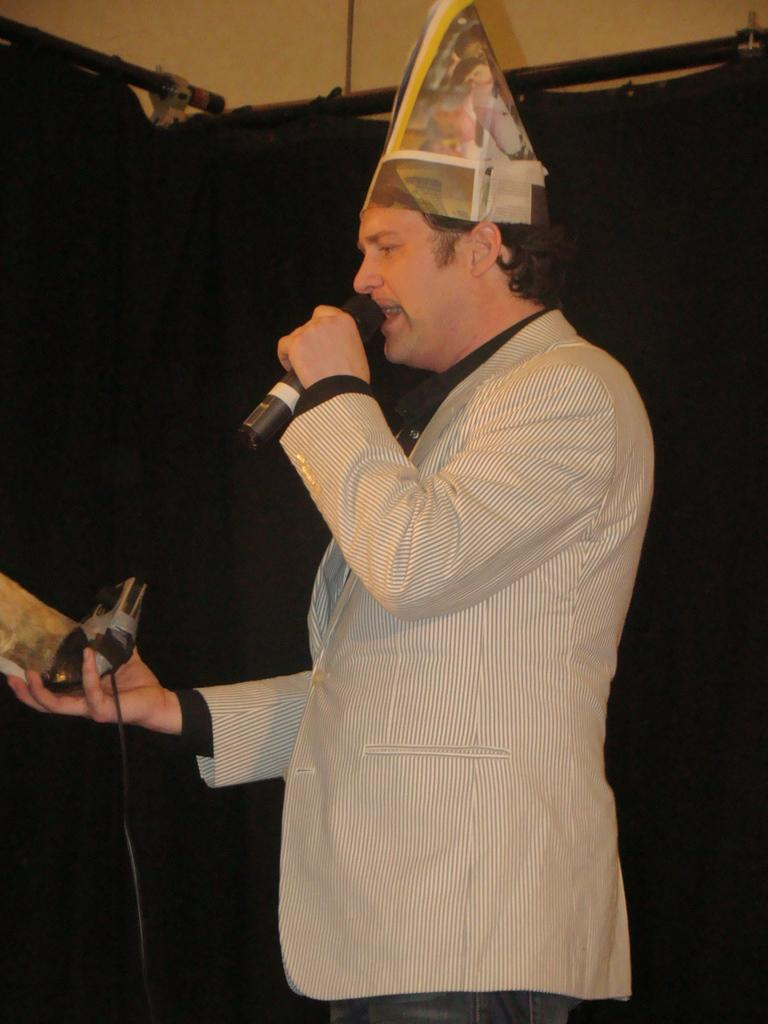What is the main subject of the image? The main subject of the image is a man. What is the man doing in the image? The man is standing in the image. What object is the man holding in the image? The man is holding a microphone in the image. What type of accessory is the man wearing on his head? The man is wearing a hat on his head. What type of string instrument is the man playing in the image? There is no string instrument present in the image; the man is holding a microphone. What type of silver object is visible in the image? There is no silver object visible in the image. 